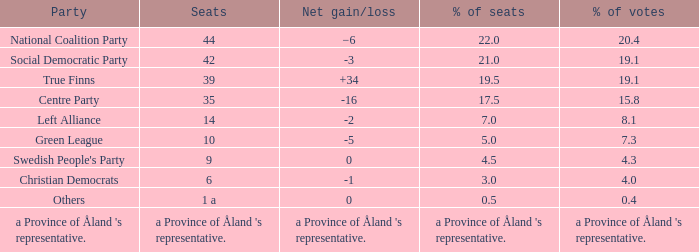When there was a net increase/decrease of +34, what was the proportion of seats that party possessed? 19.5. 